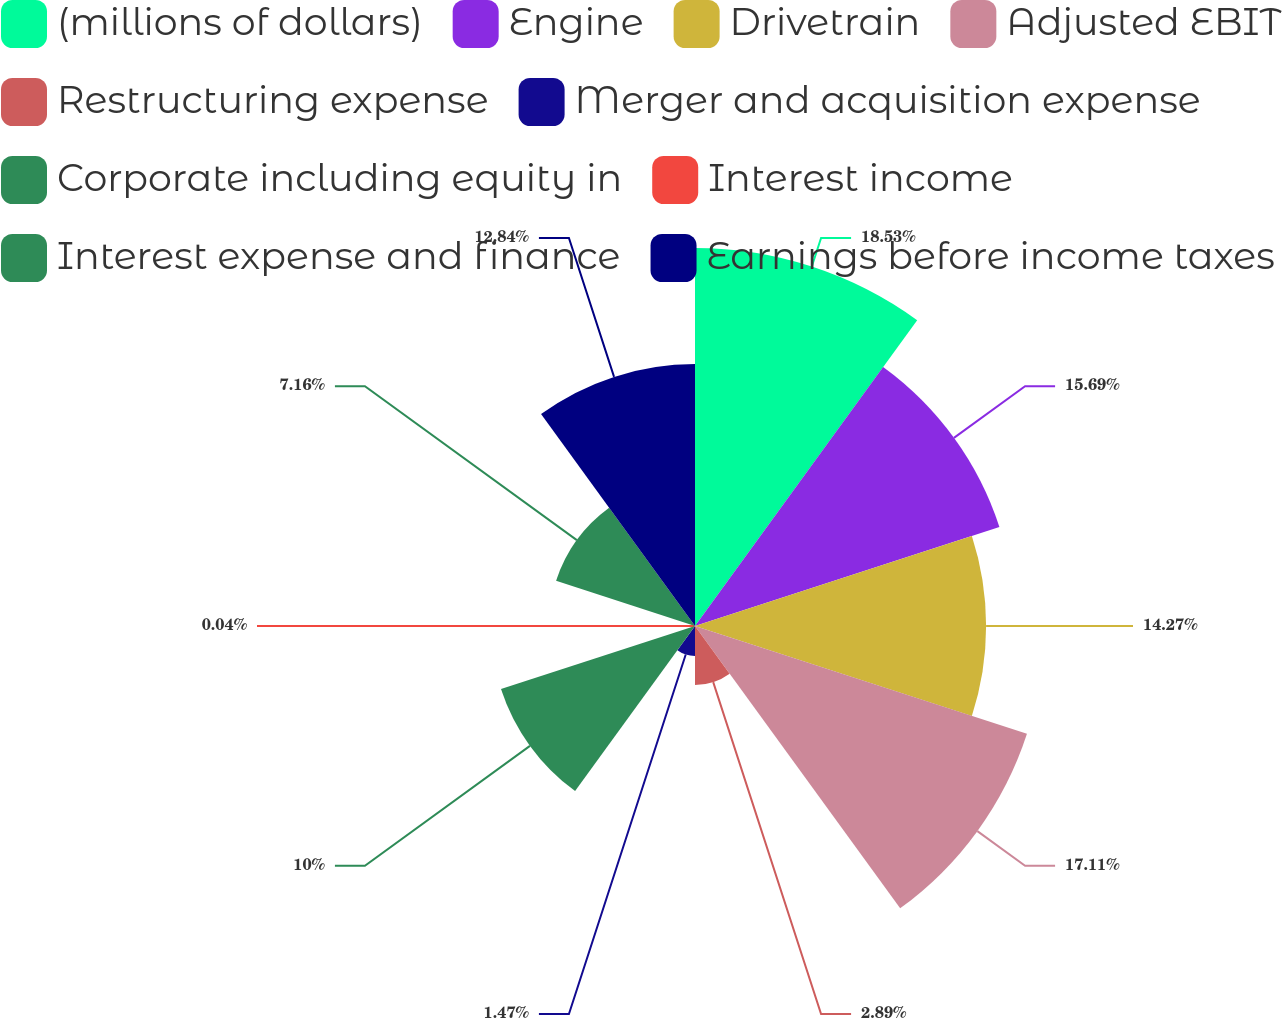Convert chart to OTSL. <chart><loc_0><loc_0><loc_500><loc_500><pie_chart><fcel>(millions of dollars)<fcel>Engine<fcel>Drivetrain<fcel>Adjusted EBIT<fcel>Restructuring expense<fcel>Merger and acquisition expense<fcel>Corporate including equity in<fcel>Interest income<fcel>Interest expense and finance<fcel>Earnings before income taxes<nl><fcel>18.53%<fcel>15.69%<fcel>14.27%<fcel>17.11%<fcel>2.89%<fcel>1.47%<fcel>10.0%<fcel>0.04%<fcel>7.16%<fcel>12.84%<nl></chart> 